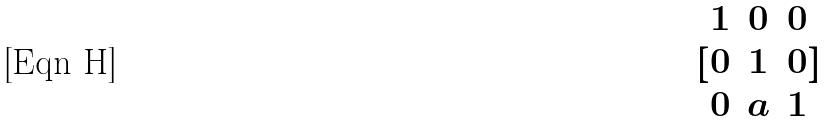<formula> <loc_0><loc_0><loc_500><loc_500>[ \begin{matrix} 1 & 0 & 0 \\ 0 & 1 & 0 \\ 0 & a & 1 \end{matrix} ]</formula> 